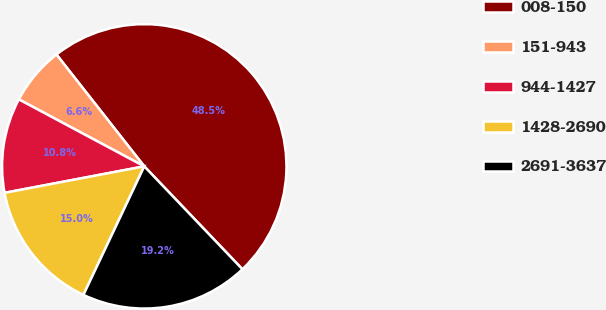<chart> <loc_0><loc_0><loc_500><loc_500><pie_chart><fcel>008-150<fcel>151-943<fcel>944-1427<fcel>1428-2690<fcel>2691-3637<nl><fcel>48.47%<fcel>6.6%<fcel>10.79%<fcel>14.98%<fcel>19.16%<nl></chart> 